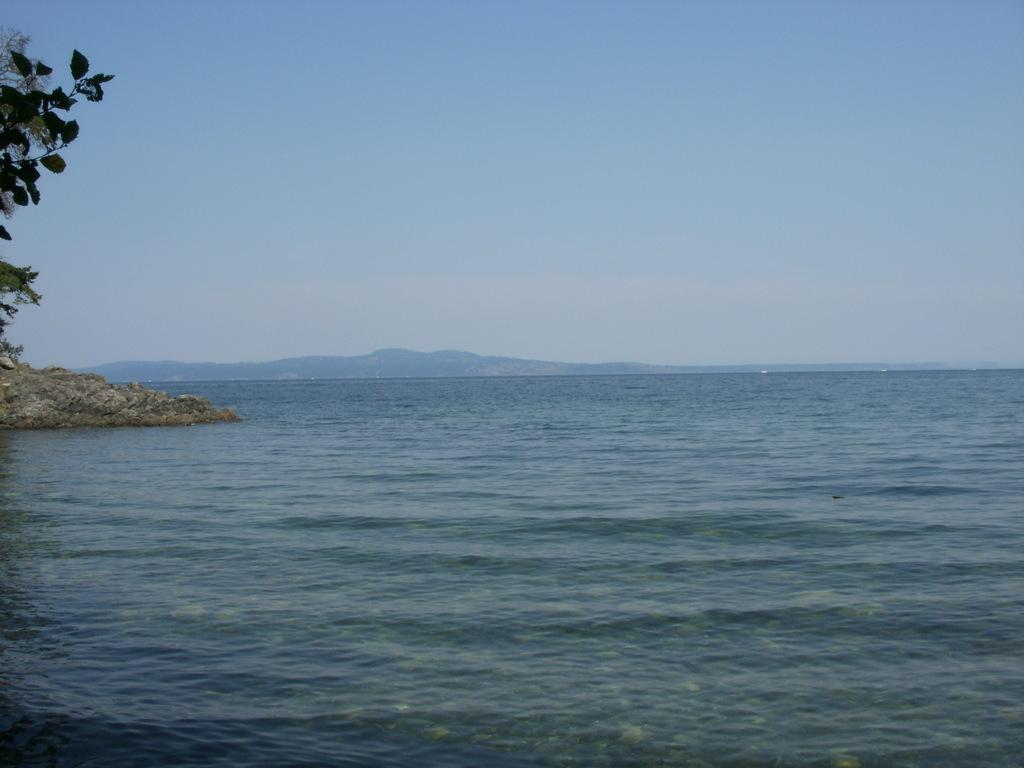What is the main subject of the image? The main subject of the image is a sea with water flowing. Are there any objects or structures in the image? Yes, there is a rock in the image. What type of vegetation is present in the image? There is a tree in the image. What can be seen in the distance in the image? In the background, there appear to be hills. How many lizards are climbing the tree in the image? There are no lizards present in the image; it only features a tree and a sea with water flowing. Is there a kite flying in the sky in the image? There is no kite visible in the image; it only depicts a sea, a rock, a tree, and hills in the background. 